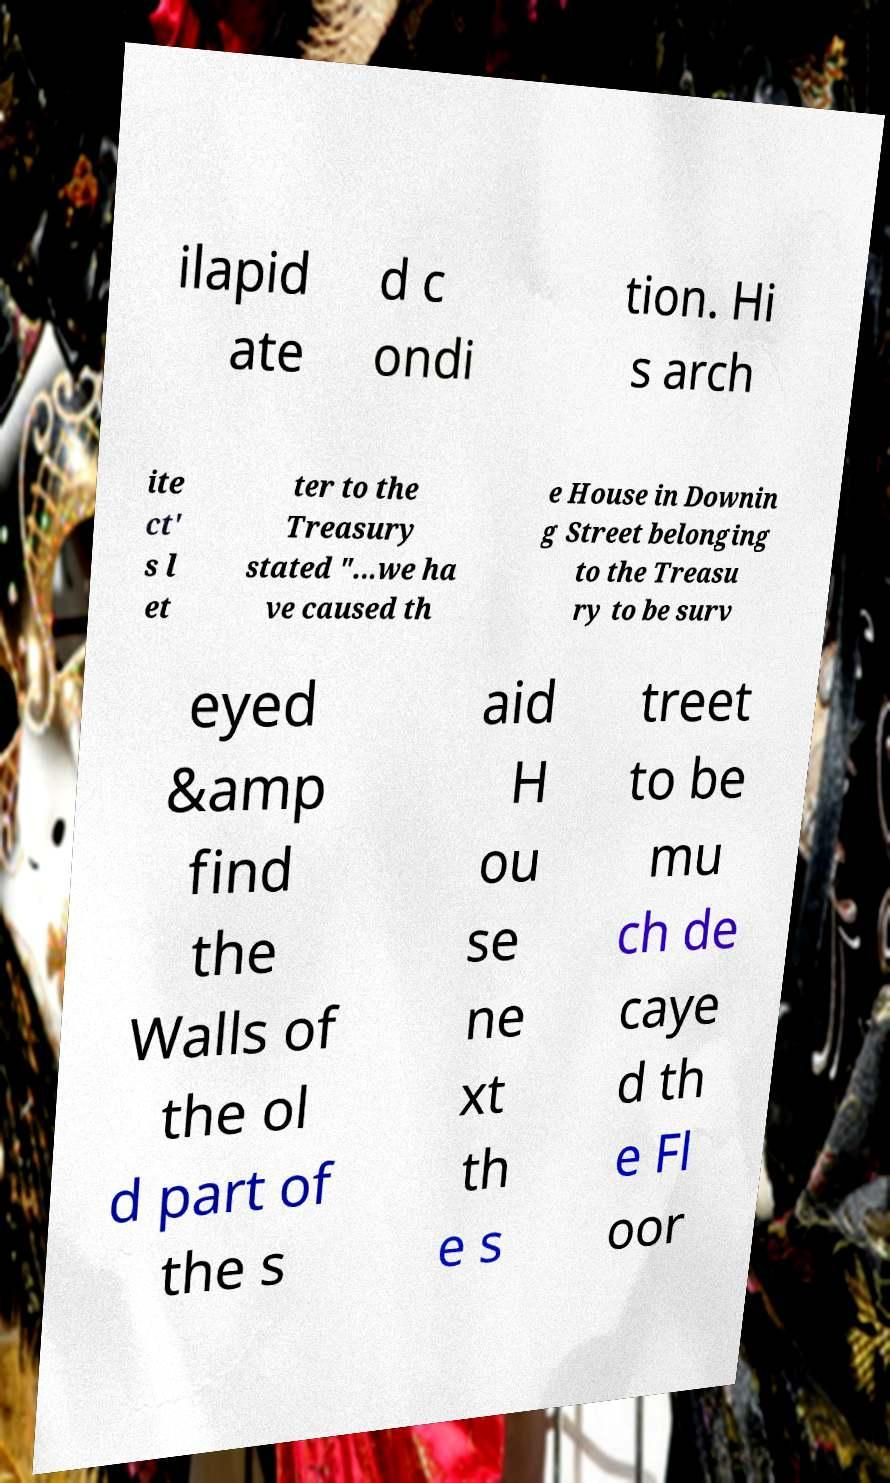What messages or text are displayed in this image? I need them in a readable, typed format. ilapid ate d c ondi tion. Hi s arch ite ct' s l et ter to the Treasury stated "...we ha ve caused th e House in Downin g Street belonging to the Treasu ry to be surv eyed &amp find the Walls of the ol d part of the s aid H ou se ne xt th e s treet to be mu ch de caye d th e Fl oor 